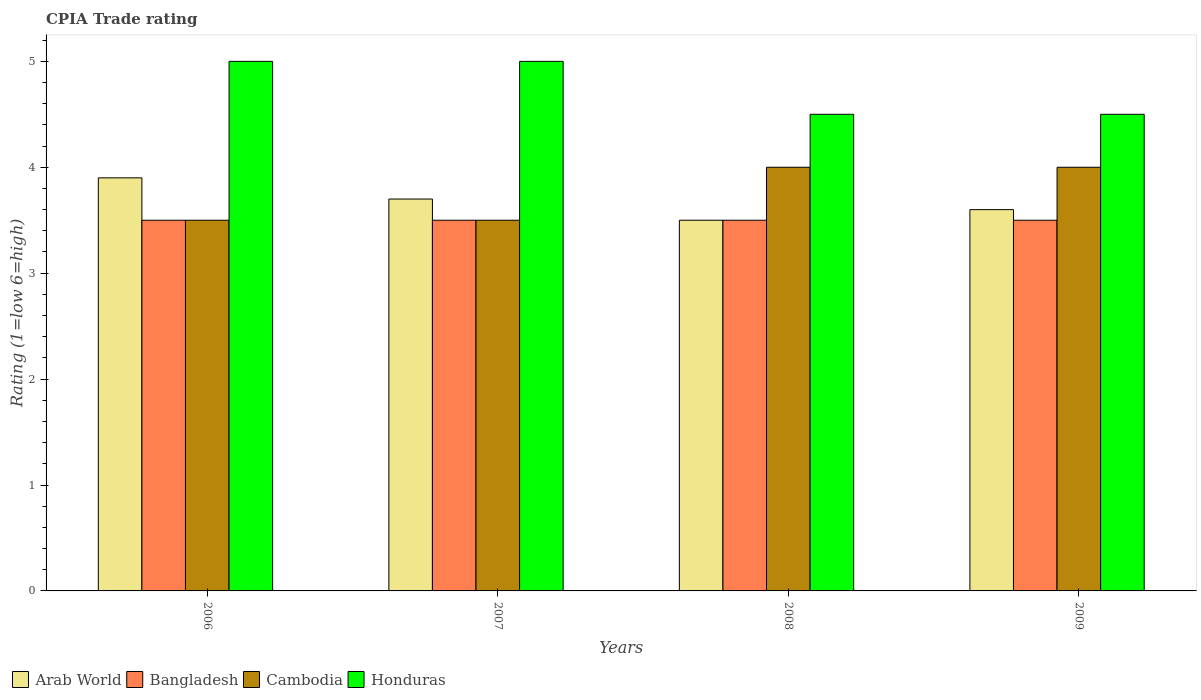How many groups of bars are there?
Keep it short and to the point. 4. Are the number of bars per tick equal to the number of legend labels?
Provide a short and direct response. Yes. How many bars are there on the 1st tick from the left?
Give a very brief answer. 4. How many bars are there on the 2nd tick from the right?
Offer a terse response. 4. What is the CPIA rating in Arab World in 2007?
Offer a very short reply. 3.7. Across all years, what is the minimum CPIA rating in Arab World?
Your answer should be very brief. 3.5. In which year was the CPIA rating in Honduras minimum?
Give a very brief answer. 2008. What is the difference between the CPIA rating in Bangladesh in 2006 and that in 2007?
Your answer should be compact. 0. What is the difference between the CPIA rating in Cambodia in 2008 and the CPIA rating in Honduras in 2009?
Offer a very short reply. -0.5. What is the average CPIA rating in Arab World per year?
Give a very brief answer. 3.67. In the year 2007, what is the difference between the CPIA rating in Honduras and CPIA rating in Cambodia?
Make the answer very short. 1.5. In how many years, is the CPIA rating in Cambodia greater than 1?
Offer a very short reply. 4. What is the ratio of the CPIA rating in Bangladesh in 2007 to that in 2008?
Provide a short and direct response. 1. Is the difference between the CPIA rating in Honduras in 2006 and 2008 greater than the difference between the CPIA rating in Cambodia in 2006 and 2008?
Keep it short and to the point. Yes. What is the difference between the highest and the second highest CPIA rating in Cambodia?
Provide a succinct answer. 0. What is the difference between the highest and the lowest CPIA rating in Arab World?
Offer a terse response. 0.4. What does the 4th bar from the left in 2008 represents?
Provide a short and direct response. Honduras. What does the 1st bar from the right in 2007 represents?
Your answer should be compact. Honduras. How many years are there in the graph?
Make the answer very short. 4. Does the graph contain any zero values?
Ensure brevity in your answer.  No. Does the graph contain grids?
Make the answer very short. No. Where does the legend appear in the graph?
Keep it short and to the point. Bottom left. How many legend labels are there?
Your answer should be very brief. 4. How are the legend labels stacked?
Make the answer very short. Horizontal. What is the title of the graph?
Ensure brevity in your answer.  CPIA Trade rating. What is the label or title of the Y-axis?
Offer a terse response. Rating (1=low 6=high). What is the Rating (1=low 6=high) of Bangladesh in 2006?
Ensure brevity in your answer.  3.5. What is the Rating (1=low 6=high) in Cambodia in 2006?
Give a very brief answer. 3.5. What is the Rating (1=low 6=high) of Honduras in 2006?
Your answer should be compact. 5. What is the Rating (1=low 6=high) of Arab World in 2007?
Provide a short and direct response. 3.7. What is the Rating (1=low 6=high) in Bangladesh in 2007?
Offer a very short reply. 3.5. What is the Rating (1=low 6=high) in Cambodia in 2007?
Ensure brevity in your answer.  3.5. What is the Rating (1=low 6=high) in Honduras in 2007?
Provide a succinct answer. 5. What is the Rating (1=low 6=high) of Bangladesh in 2008?
Your answer should be very brief. 3.5. What is the Rating (1=low 6=high) of Cambodia in 2008?
Keep it short and to the point. 4. What is the Rating (1=low 6=high) in Bangladesh in 2009?
Offer a terse response. 3.5. What is the Rating (1=low 6=high) in Cambodia in 2009?
Offer a very short reply. 4. What is the Rating (1=low 6=high) in Honduras in 2009?
Provide a short and direct response. 4.5. Across all years, what is the maximum Rating (1=low 6=high) in Bangladesh?
Offer a very short reply. 3.5. Across all years, what is the maximum Rating (1=low 6=high) in Cambodia?
Make the answer very short. 4. Across all years, what is the minimum Rating (1=low 6=high) of Honduras?
Provide a succinct answer. 4.5. What is the total Rating (1=low 6=high) of Arab World in the graph?
Give a very brief answer. 14.7. What is the total Rating (1=low 6=high) of Honduras in the graph?
Provide a short and direct response. 19. What is the difference between the Rating (1=low 6=high) in Arab World in 2006 and that in 2007?
Make the answer very short. 0.2. What is the difference between the Rating (1=low 6=high) in Honduras in 2006 and that in 2007?
Ensure brevity in your answer.  0. What is the difference between the Rating (1=low 6=high) of Arab World in 2006 and that in 2008?
Your response must be concise. 0.4. What is the difference between the Rating (1=low 6=high) of Bangladesh in 2006 and that in 2008?
Give a very brief answer. 0. What is the difference between the Rating (1=low 6=high) in Honduras in 2006 and that in 2008?
Your response must be concise. 0.5. What is the difference between the Rating (1=low 6=high) of Arab World in 2006 and that in 2009?
Provide a succinct answer. 0.3. What is the difference between the Rating (1=low 6=high) of Bangladesh in 2006 and that in 2009?
Your answer should be very brief. 0. What is the difference between the Rating (1=low 6=high) in Honduras in 2006 and that in 2009?
Your response must be concise. 0.5. What is the difference between the Rating (1=low 6=high) in Arab World in 2007 and that in 2009?
Provide a succinct answer. 0.1. What is the difference between the Rating (1=low 6=high) in Bangladesh in 2007 and that in 2009?
Offer a very short reply. 0. What is the difference between the Rating (1=low 6=high) of Bangladesh in 2008 and that in 2009?
Your answer should be very brief. 0. What is the difference between the Rating (1=low 6=high) of Cambodia in 2008 and that in 2009?
Your answer should be very brief. 0. What is the difference between the Rating (1=low 6=high) of Honduras in 2008 and that in 2009?
Ensure brevity in your answer.  0. What is the difference between the Rating (1=low 6=high) of Arab World in 2006 and the Rating (1=low 6=high) of Bangladesh in 2007?
Give a very brief answer. 0.4. What is the difference between the Rating (1=low 6=high) in Bangladesh in 2006 and the Rating (1=low 6=high) in Cambodia in 2007?
Offer a terse response. 0. What is the difference between the Rating (1=low 6=high) in Arab World in 2006 and the Rating (1=low 6=high) in Bangladesh in 2008?
Make the answer very short. 0.4. What is the difference between the Rating (1=low 6=high) of Arab World in 2006 and the Rating (1=low 6=high) of Honduras in 2008?
Provide a short and direct response. -0.6. What is the difference between the Rating (1=low 6=high) of Bangladesh in 2006 and the Rating (1=low 6=high) of Honduras in 2008?
Your answer should be compact. -1. What is the difference between the Rating (1=low 6=high) of Arab World in 2006 and the Rating (1=low 6=high) of Cambodia in 2009?
Give a very brief answer. -0.1. What is the difference between the Rating (1=low 6=high) in Bangladesh in 2006 and the Rating (1=low 6=high) in Honduras in 2009?
Make the answer very short. -1. What is the difference between the Rating (1=low 6=high) in Cambodia in 2006 and the Rating (1=low 6=high) in Honduras in 2009?
Provide a succinct answer. -1. What is the difference between the Rating (1=low 6=high) in Arab World in 2007 and the Rating (1=low 6=high) in Cambodia in 2008?
Your response must be concise. -0.3. What is the difference between the Rating (1=low 6=high) in Bangladesh in 2007 and the Rating (1=low 6=high) in Honduras in 2008?
Make the answer very short. -1. What is the difference between the Rating (1=low 6=high) in Cambodia in 2007 and the Rating (1=low 6=high) in Honduras in 2008?
Offer a very short reply. -1. What is the difference between the Rating (1=low 6=high) in Bangladesh in 2007 and the Rating (1=low 6=high) in Cambodia in 2009?
Provide a short and direct response. -0.5. What is the difference between the Rating (1=low 6=high) in Arab World in 2008 and the Rating (1=low 6=high) in Cambodia in 2009?
Provide a succinct answer. -0.5. What is the difference between the Rating (1=low 6=high) in Arab World in 2008 and the Rating (1=low 6=high) in Honduras in 2009?
Provide a short and direct response. -1. What is the difference between the Rating (1=low 6=high) of Bangladesh in 2008 and the Rating (1=low 6=high) of Cambodia in 2009?
Your response must be concise. -0.5. What is the difference between the Rating (1=low 6=high) in Bangladesh in 2008 and the Rating (1=low 6=high) in Honduras in 2009?
Your response must be concise. -1. What is the difference between the Rating (1=low 6=high) of Cambodia in 2008 and the Rating (1=low 6=high) of Honduras in 2009?
Give a very brief answer. -0.5. What is the average Rating (1=low 6=high) in Arab World per year?
Ensure brevity in your answer.  3.67. What is the average Rating (1=low 6=high) of Cambodia per year?
Make the answer very short. 3.75. What is the average Rating (1=low 6=high) in Honduras per year?
Your answer should be very brief. 4.75. In the year 2006, what is the difference between the Rating (1=low 6=high) in Arab World and Rating (1=low 6=high) in Cambodia?
Offer a very short reply. 0.4. In the year 2006, what is the difference between the Rating (1=low 6=high) in Arab World and Rating (1=low 6=high) in Honduras?
Offer a terse response. -1.1. In the year 2006, what is the difference between the Rating (1=low 6=high) in Bangladesh and Rating (1=low 6=high) in Cambodia?
Your response must be concise. 0. In the year 2006, what is the difference between the Rating (1=low 6=high) in Cambodia and Rating (1=low 6=high) in Honduras?
Provide a succinct answer. -1.5. In the year 2007, what is the difference between the Rating (1=low 6=high) of Arab World and Rating (1=low 6=high) of Bangladesh?
Your answer should be very brief. 0.2. In the year 2007, what is the difference between the Rating (1=low 6=high) of Bangladesh and Rating (1=low 6=high) of Cambodia?
Offer a very short reply. 0. In the year 2008, what is the difference between the Rating (1=low 6=high) of Arab World and Rating (1=low 6=high) of Cambodia?
Ensure brevity in your answer.  -0.5. In the year 2008, what is the difference between the Rating (1=low 6=high) in Cambodia and Rating (1=low 6=high) in Honduras?
Provide a succinct answer. -0.5. In the year 2009, what is the difference between the Rating (1=low 6=high) of Arab World and Rating (1=low 6=high) of Honduras?
Your answer should be very brief. -0.9. In the year 2009, what is the difference between the Rating (1=low 6=high) in Bangladesh and Rating (1=low 6=high) in Honduras?
Make the answer very short. -1. In the year 2009, what is the difference between the Rating (1=low 6=high) of Cambodia and Rating (1=low 6=high) of Honduras?
Provide a short and direct response. -0.5. What is the ratio of the Rating (1=low 6=high) of Arab World in 2006 to that in 2007?
Your answer should be very brief. 1.05. What is the ratio of the Rating (1=low 6=high) of Bangladesh in 2006 to that in 2007?
Ensure brevity in your answer.  1. What is the ratio of the Rating (1=low 6=high) in Cambodia in 2006 to that in 2007?
Provide a short and direct response. 1. What is the ratio of the Rating (1=low 6=high) of Arab World in 2006 to that in 2008?
Offer a terse response. 1.11. What is the ratio of the Rating (1=low 6=high) in Cambodia in 2006 to that in 2008?
Your answer should be very brief. 0.88. What is the ratio of the Rating (1=low 6=high) in Honduras in 2006 to that in 2008?
Provide a succinct answer. 1.11. What is the ratio of the Rating (1=low 6=high) in Arab World in 2006 to that in 2009?
Your answer should be very brief. 1.08. What is the ratio of the Rating (1=low 6=high) in Bangladesh in 2006 to that in 2009?
Your answer should be compact. 1. What is the ratio of the Rating (1=low 6=high) in Honduras in 2006 to that in 2009?
Give a very brief answer. 1.11. What is the ratio of the Rating (1=low 6=high) of Arab World in 2007 to that in 2008?
Offer a terse response. 1.06. What is the ratio of the Rating (1=low 6=high) in Bangladesh in 2007 to that in 2008?
Provide a short and direct response. 1. What is the ratio of the Rating (1=low 6=high) of Arab World in 2007 to that in 2009?
Your answer should be compact. 1.03. What is the ratio of the Rating (1=low 6=high) of Bangladesh in 2007 to that in 2009?
Provide a succinct answer. 1. What is the ratio of the Rating (1=low 6=high) in Arab World in 2008 to that in 2009?
Your answer should be very brief. 0.97. What is the ratio of the Rating (1=low 6=high) in Bangladesh in 2008 to that in 2009?
Keep it short and to the point. 1. What is the ratio of the Rating (1=low 6=high) of Cambodia in 2008 to that in 2009?
Your answer should be compact. 1. What is the difference between the highest and the second highest Rating (1=low 6=high) of Bangladesh?
Your response must be concise. 0. What is the difference between the highest and the second highest Rating (1=low 6=high) of Cambodia?
Your answer should be very brief. 0. What is the difference between the highest and the lowest Rating (1=low 6=high) of Arab World?
Your response must be concise. 0.4. What is the difference between the highest and the lowest Rating (1=low 6=high) of Bangladesh?
Make the answer very short. 0. 